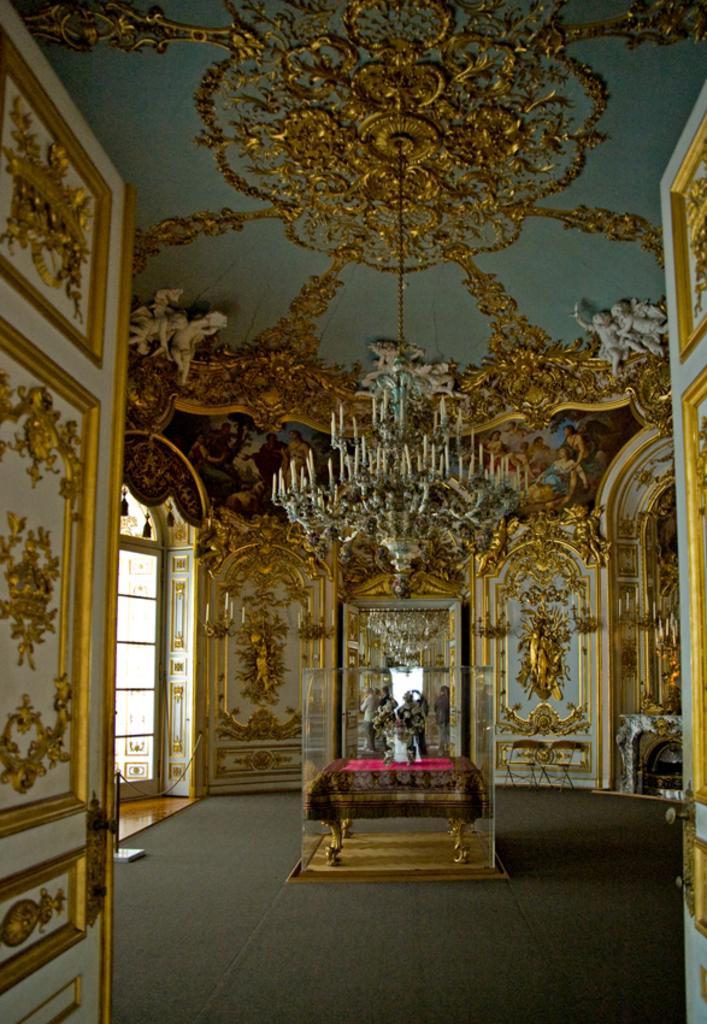How would you summarize this image in a sentence or two? In this image we can see designed ceiling, design walls, designed doors and floor with carpet. Middle of the room there is a glass box. In that glass box there is a table and an object. Far we can see people. 